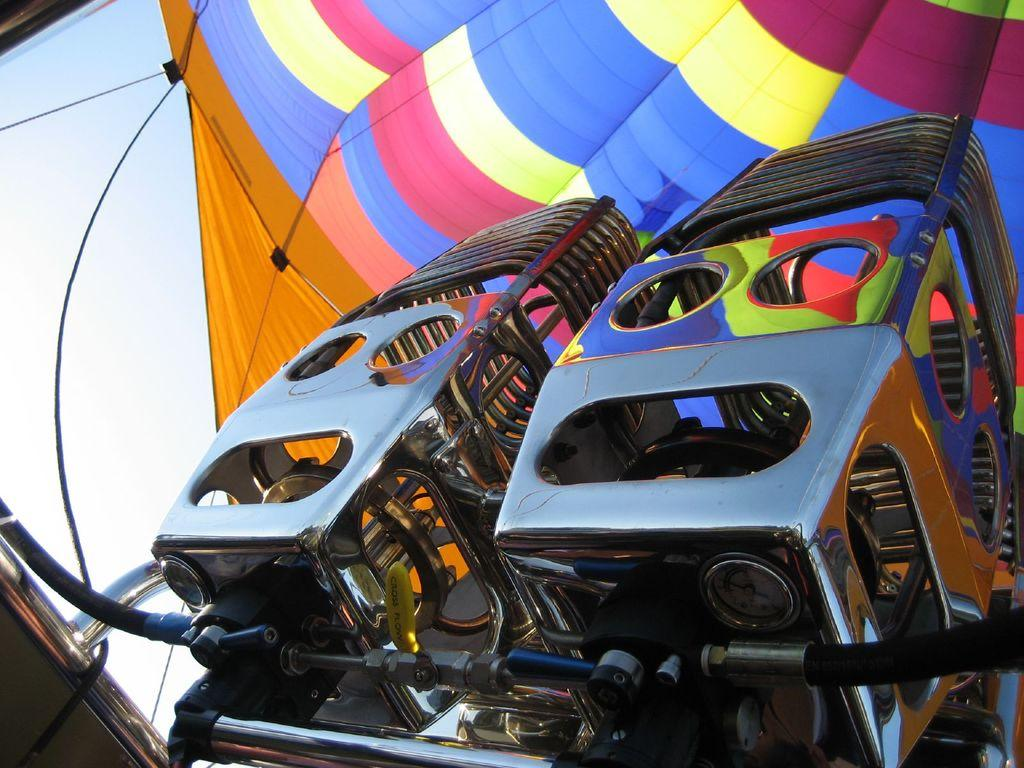What type of objects can be seen in the image? There are metal objects in the image. What is the main subject of the image? There is an air balloon in the image. What can be seen in the background of the image? The sky is visible in the background of the image. What type of hospital is depicted in the image? There is no hospital present in the image; it features an air balloon and metal objects. How does the magic work in the image? There is no magic present in the image; it is a realistic scene featuring an air balloon and metal objects. 